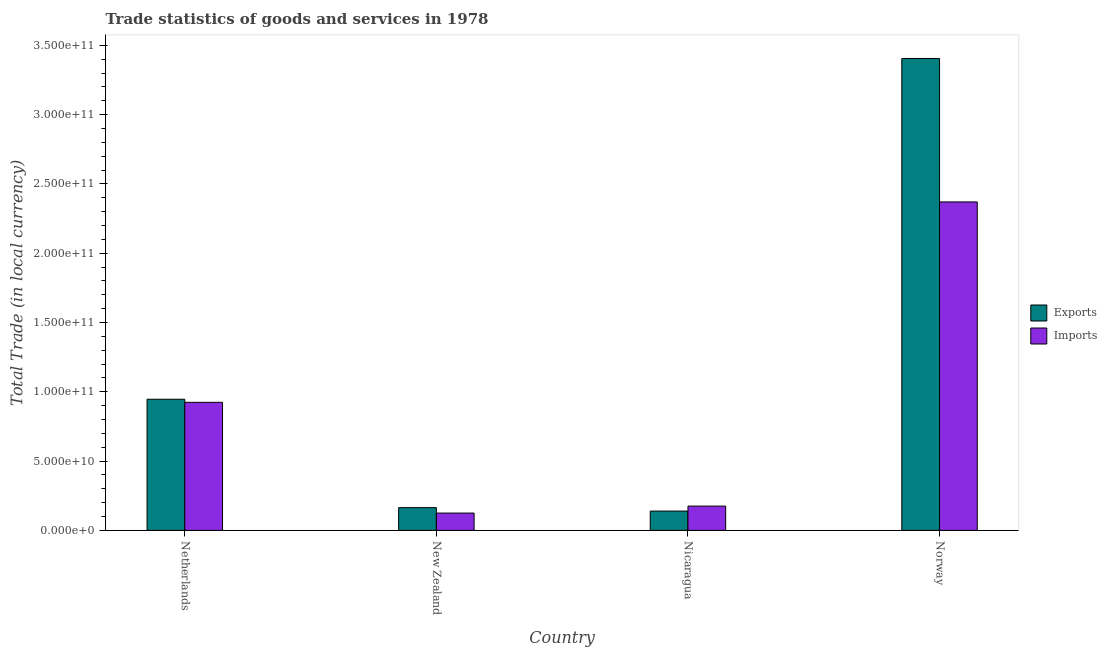Are the number of bars per tick equal to the number of legend labels?
Keep it short and to the point. Yes. How many bars are there on the 3rd tick from the left?
Your response must be concise. 2. What is the imports of goods and services in New Zealand?
Keep it short and to the point. 1.25e+1. Across all countries, what is the maximum imports of goods and services?
Your response must be concise. 2.37e+11. Across all countries, what is the minimum export of goods and services?
Offer a terse response. 1.39e+1. In which country was the export of goods and services maximum?
Keep it short and to the point. Norway. In which country was the imports of goods and services minimum?
Your answer should be very brief. New Zealand. What is the total imports of goods and services in the graph?
Ensure brevity in your answer.  3.59e+11. What is the difference between the export of goods and services in New Zealand and that in Norway?
Your response must be concise. -3.24e+11. What is the difference between the imports of goods and services in New Zealand and the export of goods and services in Norway?
Offer a very short reply. -3.28e+11. What is the average export of goods and services per country?
Offer a terse response. 1.16e+11. What is the difference between the imports of goods and services and export of goods and services in New Zealand?
Provide a short and direct response. -3.92e+09. What is the ratio of the imports of goods and services in Netherlands to that in Nicaragua?
Your answer should be compact. 5.27. What is the difference between the highest and the second highest imports of goods and services?
Your answer should be compact. 1.45e+11. What is the difference between the highest and the lowest imports of goods and services?
Your answer should be very brief. 2.25e+11. In how many countries, is the imports of goods and services greater than the average imports of goods and services taken over all countries?
Provide a short and direct response. 2. What does the 1st bar from the left in Nicaragua represents?
Your answer should be very brief. Exports. What does the 2nd bar from the right in New Zealand represents?
Give a very brief answer. Exports. How many bars are there?
Your answer should be compact. 8. Are all the bars in the graph horizontal?
Make the answer very short. No. How many countries are there in the graph?
Your answer should be compact. 4. Are the values on the major ticks of Y-axis written in scientific E-notation?
Offer a terse response. Yes. What is the title of the graph?
Offer a very short reply. Trade statistics of goods and services in 1978. What is the label or title of the Y-axis?
Give a very brief answer. Total Trade (in local currency). What is the Total Trade (in local currency) in Exports in Netherlands?
Your response must be concise. 9.46e+1. What is the Total Trade (in local currency) of Imports in Netherlands?
Your answer should be very brief. 9.24e+1. What is the Total Trade (in local currency) of Exports in New Zealand?
Your answer should be very brief. 1.64e+1. What is the Total Trade (in local currency) of Imports in New Zealand?
Ensure brevity in your answer.  1.25e+1. What is the Total Trade (in local currency) in Exports in Nicaragua?
Offer a very short reply. 1.39e+1. What is the Total Trade (in local currency) in Imports in Nicaragua?
Ensure brevity in your answer.  1.75e+1. What is the Total Trade (in local currency) in Exports in Norway?
Provide a short and direct response. 3.41e+11. What is the Total Trade (in local currency) of Imports in Norway?
Your response must be concise. 2.37e+11. Across all countries, what is the maximum Total Trade (in local currency) of Exports?
Make the answer very short. 3.41e+11. Across all countries, what is the maximum Total Trade (in local currency) of Imports?
Your response must be concise. 2.37e+11. Across all countries, what is the minimum Total Trade (in local currency) in Exports?
Make the answer very short. 1.39e+1. Across all countries, what is the minimum Total Trade (in local currency) in Imports?
Provide a short and direct response. 1.25e+1. What is the total Total Trade (in local currency) in Exports in the graph?
Ensure brevity in your answer.  4.66e+11. What is the total Total Trade (in local currency) of Imports in the graph?
Your response must be concise. 3.59e+11. What is the difference between the Total Trade (in local currency) of Exports in Netherlands and that in New Zealand?
Your response must be concise. 7.82e+1. What is the difference between the Total Trade (in local currency) in Imports in Netherlands and that in New Zealand?
Ensure brevity in your answer.  7.99e+1. What is the difference between the Total Trade (in local currency) of Exports in Netherlands and that in Nicaragua?
Ensure brevity in your answer.  8.07e+1. What is the difference between the Total Trade (in local currency) of Imports in Netherlands and that in Nicaragua?
Your answer should be compact. 7.49e+1. What is the difference between the Total Trade (in local currency) of Exports in Netherlands and that in Norway?
Make the answer very short. -2.46e+11. What is the difference between the Total Trade (in local currency) in Imports in Netherlands and that in Norway?
Offer a very short reply. -1.45e+11. What is the difference between the Total Trade (in local currency) of Exports in New Zealand and that in Nicaragua?
Keep it short and to the point. 2.49e+09. What is the difference between the Total Trade (in local currency) of Imports in New Zealand and that in Nicaragua?
Offer a very short reply. -5.02e+09. What is the difference between the Total Trade (in local currency) of Exports in New Zealand and that in Norway?
Give a very brief answer. -3.24e+11. What is the difference between the Total Trade (in local currency) of Imports in New Zealand and that in Norway?
Give a very brief answer. -2.25e+11. What is the difference between the Total Trade (in local currency) in Exports in Nicaragua and that in Norway?
Offer a terse response. -3.27e+11. What is the difference between the Total Trade (in local currency) in Imports in Nicaragua and that in Norway?
Keep it short and to the point. -2.19e+11. What is the difference between the Total Trade (in local currency) in Exports in Netherlands and the Total Trade (in local currency) in Imports in New Zealand?
Provide a short and direct response. 8.21e+1. What is the difference between the Total Trade (in local currency) in Exports in Netherlands and the Total Trade (in local currency) in Imports in Nicaragua?
Your answer should be very brief. 7.71e+1. What is the difference between the Total Trade (in local currency) of Exports in Netherlands and the Total Trade (in local currency) of Imports in Norway?
Make the answer very short. -1.42e+11. What is the difference between the Total Trade (in local currency) of Exports in New Zealand and the Total Trade (in local currency) of Imports in Nicaragua?
Your answer should be compact. -1.10e+09. What is the difference between the Total Trade (in local currency) of Exports in New Zealand and the Total Trade (in local currency) of Imports in Norway?
Keep it short and to the point. -2.21e+11. What is the difference between the Total Trade (in local currency) in Exports in Nicaragua and the Total Trade (in local currency) in Imports in Norway?
Make the answer very short. -2.23e+11. What is the average Total Trade (in local currency) of Exports per country?
Provide a succinct answer. 1.16e+11. What is the average Total Trade (in local currency) in Imports per country?
Give a very brief answer. 8.99e+1. What is the difference between the Total Trade (in local currency) of Exports and Total Trade (in local currency) of Imports in Netherlands?
Keep it short and to the point. 2.23e+09. What is the difference between the Total Trade (in local currency) in Exports and Total Trade (in local currency) in Imports in New Zealand?
Your answer should be very brief. 3.92e+09. What is the difference between the Total Trade (in local currency) of Exports and Total Trade (in local currency) of Imports in Nicaragua?
Offer a terse response. -3.59e+09. What is the difference between the Total Trade (in local currency) of Exports and Total Trade (in local currency) of Imports in Norway?
Provide a short and direct response. 1.04e+11. What is the ratio of the Total Trade (in local currency) in Exports in Netherlands to that in New Zealand?
Offer a terse response. 5.76. What is the ratio of the Total Trade (in local currency) of Imports in Netherlands to that in New Zealand?
Give a very brief answer. 7.39. What is the ratio of the Total Trade (in local currency) in Exports in Netherlands to that in Nicaragua?
Your answer should be very brief. 6.79. What is the ratio of the Total Trade (in local currency) of Imports in Netherlands to that in Nicaragua?
Provide a short and direct response. 5.27. What is the ratio of the Total Trade (in local currency) of Exports in Netherlands to that in Norway?
Provide a short and direct response. 0.28. What is the ratio of the Total Trade (in local currency) of Imports in Netherlands to that in Norway?
Your response must be concise. 0.39. What is the ratio of the Total Trade (in local currency) of Exports in New Zealand to that in Nicaragua?
Offer a terse response. 1.18. What is the ratio of the Total Trade (in local currency) in Imports in New Zealand to that in Nicaragua?
Your answer should be very brief. 0.71. What is the ratio of the Total Trade (in local currency) of Exports in New Zealand to that in Norway?
Your answer should be very brief. 0.05. What is the ratio of the Total Trade (in local currency) of Imports in New Zealand to that in Norway?
Offer a terse response. 0.05. What is the ratio of the Total Trade (in local currency) of Exports in Nicaragua to that in Norway?
Your response must be concise. 0.04. What is the ratio of the Total Trade (in local currency) of Imports in Nicaragua to that in Norway?
Make the answer very short. 0.07. What is the difference between the highest and the second highest Total Trade (in local currency) in Exports?
Keep it short and to the point. 2.46e+11. What is the difference between the highest and the second highest Total Trade (in local currency) in Imports?
Offer a terse response. 1.45e+11. What is the difference between the highest and the lowest Total Trade (in local currency) of Exports?
Keep it short and to the point. 3.27e+11. What is the difference between the highest and the lowest Total Trade (in local currency) in Imports?
Offer a terse response. 2.25e+11. 